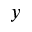Convert formula to latex. <formula><loc_0><loc_0><loc_500><loc_500>y</formula> 